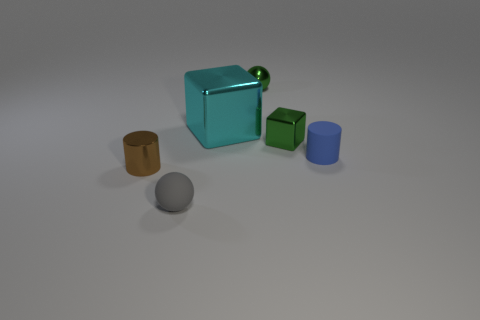Add 2 blue rubber things. How many objects exist? 8 Subtract all cylinders. How many objects are left? 4 Subtract all cyan metal things. Subtract all tiny cylinders. How many objects are left? 3 Add 3 small shiny objects. How many small shiny objects are left? 6 Add 5 tiny blue cylinders. How many tiny blue cylinders exist? 6 Subtract 0 yellow blocks. How many objects are left? 6 